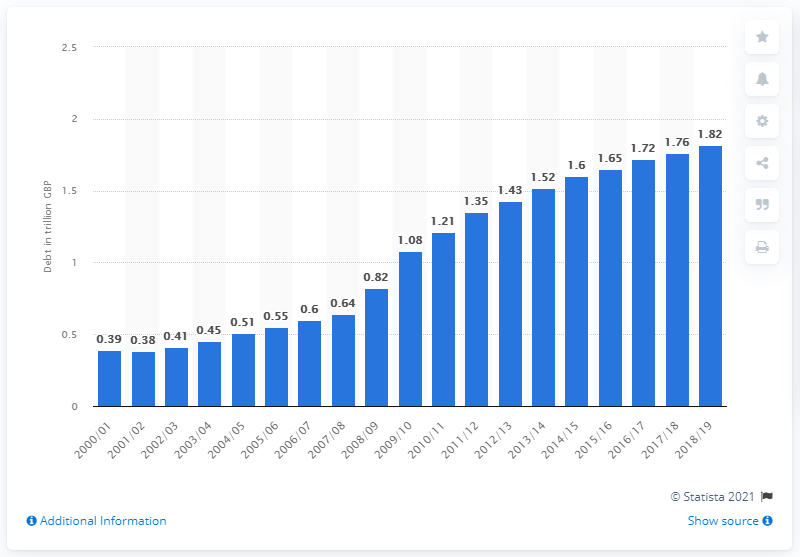Specify some key components in this picture. During the years 2000/2001, the national debt of the United Kingdom decreased. 